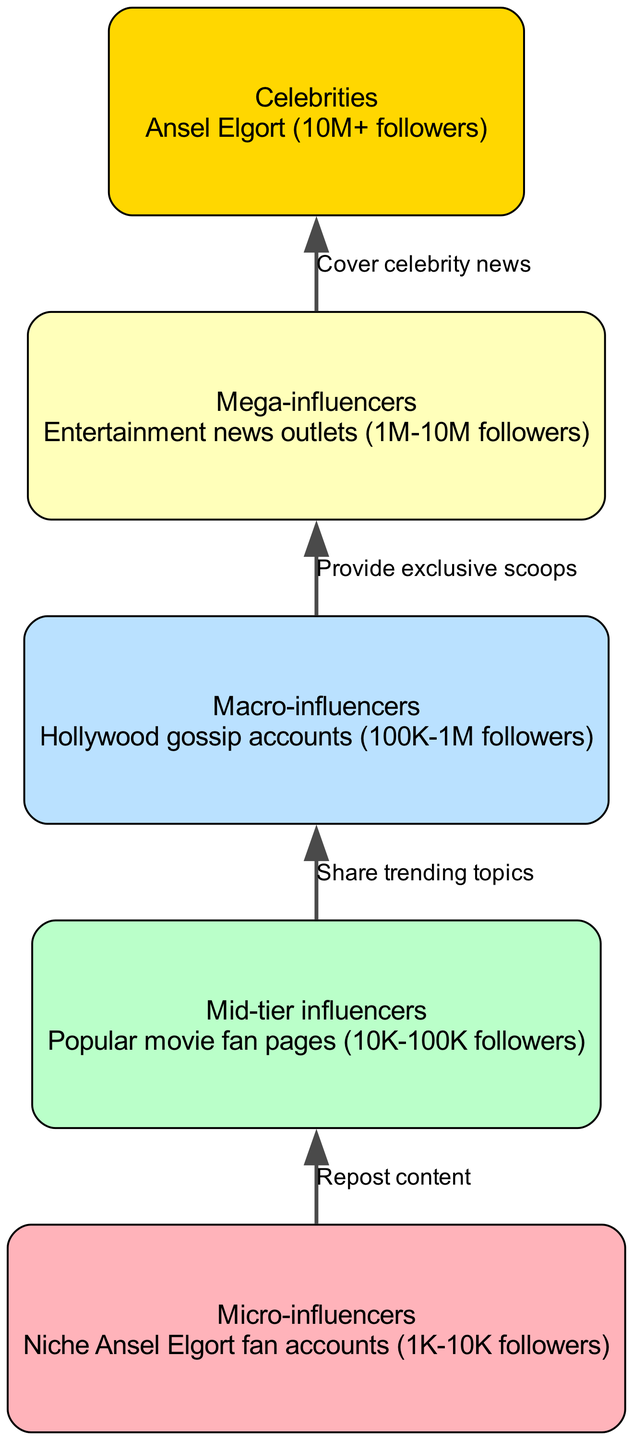What is the highest level in the food chain? The highest level in the food chain is determined by identifying the node with the highest level number. In this diagram, "Celebrities" is at level 5.
Answer: Celebrities How many nodes are in the diagram? To find the number of nodes, we count each unique element listed in the elements section of the diagram. There are five elements: Micro-influencers, Mid-tier influencers, Macro-influencers, Mega-influencers, and Celebrities.
Answer: 5 Which relationship describes the action between Micro-influencers and Mid-tier influencers? This relationship is found by looking at the specific edge that connects these two nodes. The edge indicates that Micro-influencers "Repost content" to Mid-tier influencers.
Answer: Repost content What is the level of Macro-influencers? By checking the elements listed, we can see that "Macro-influencers" is defined at level 3 in the diagram, which is clearly stated in the structure of the elements.
Answer: 3 Which influencer level provides exclusive scoops? This question requires looking at the relationship leading to a higher level. Macro-influencers provide exclusive scoops to Mega-influencers, as per the edge defined in the relationships section.
Answer: Macro-influencers What action do Mega-influencers take towards Celebrities? This asks for the specific connection from Mega-influencers to Celebrities. The relationship shows that Mega-influencers "Cover celebrity news" for Celebrities, hence identifying that specific action.
Answer: Cover celebrity news What is the connection between Mid-tier influencers and Macro-influencers? This involves checking the edge linking Mid-tier influencers to Macro-influencers. The relationship is that Mid-tier influencers "Share trending topics" with Macro-influencers.
Answer: Share trending topics What is the follower range for Micro-influencers? The follower range can be determined from the description provided in the elements section for Micro-influencers, which clearly defines their follower count as between 1K and 10K.
Answer: 1K-10K followers 